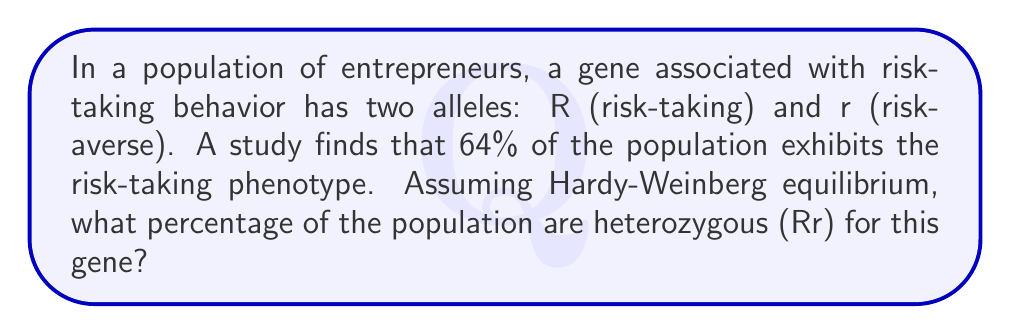Can you solve this math problem? To solve this problem, we'll use the Hardy-Weinberg equilibrium principles:

1. Let p = frequency of allele R, and q = frequency of allele r
2. We know that p + q = 1

Given that 64% of the population exhibits the risk-taking phenotype, we can assume this represents the sum of homozygous dominant (RR) and heterozygous (Rr) individuals:

$$ p^2 + 2pq = 0.64 $$

Since p + q = 1, we can substitute q = 1 - p:

$$ p^2 + 2p(1-p) = 0.64 $$

Expanding the equation:

$$ p^2 + 2p - 2p^2 = 0.64 $$
$$ -p^2 + 2p = 0.64 $$
$$ p^2 - 2p + 0.64 = 0 $$

This is a quadratic equation. We can solve it using the quadratic formula:

$$ p = \frac{-b \pm \sqrt{b^2 - 4ac}}{2a} $$

Where a = 1, b = -2, and c = 0.64

$$ p = \frac{2 \pm \sqrt{4 - 4(1)(0.64)}}{2(1)} $$
$$ p = \frac{2 \pm \sqrt{1.44}}{2} $$
$$ p = \frac{2 \pm 1.2}{2} $$

This gives us two solutions: p = 1.6 or p = 0.4

Since allele frequencies cannot be greater than 1, we take p = 0.4

Now we can calculate q:
$$ q = 1 - p = 1 - 0.4 = 0.6 $$

The frequency of heterozygotes (Rr) is given by 2pq:

$$ 2pq = 2(0.4)(0.6) = 0.48 $$

Therefore, 48% of the population are heterozygous for this gene.
Answer: 48% 